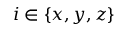Convert formula to latex. <formula><loc_0><loc_0><loc_500><loc_500>i \in \{ x , y , z \}</formula> 